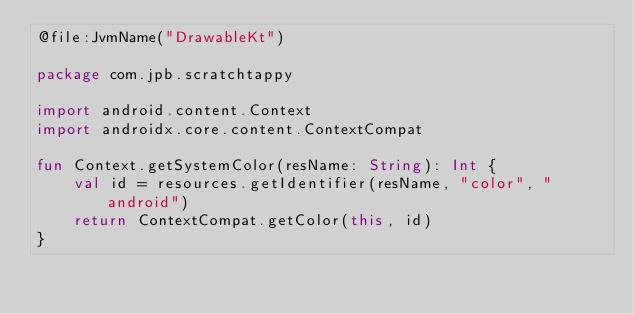Convert code to text. <code><loc_0><loc_0><loc_500><loc_500><_Kotlin_>@file:JvmName("DrawableKt")

package com.jpb.scratchtappy

import android.content.Context
import androidx.core.content.ContextCompat

fun Context.getSystemColor(resName: String): Int {
    val id = resources.getIdentifier(resName, "color", "android")
    return ContextCompat.getColor(this, id)
}
</code> 